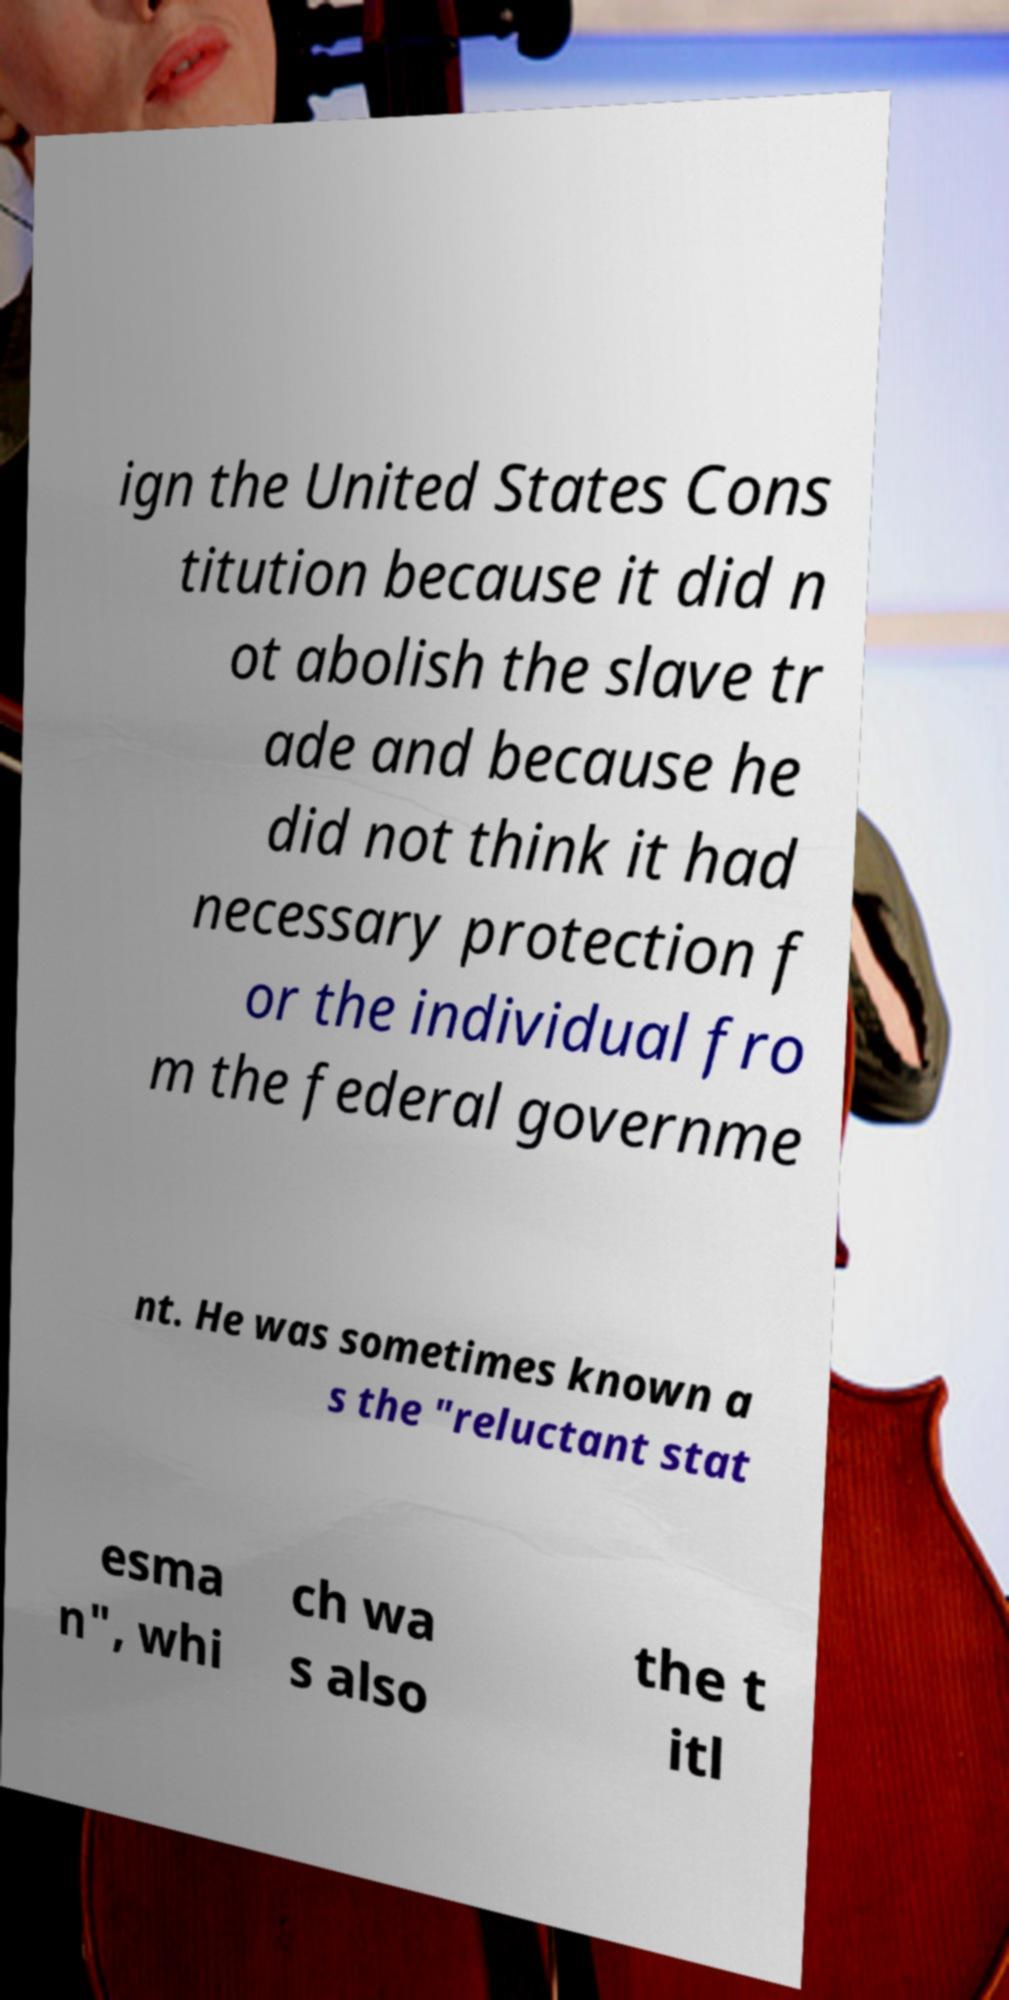Can you accurately transcribe the text from the provided image for me? ign the United States Cons titution because it did n ot abolish the slave tr ade and because he did not think it had necessary protection f or the individual fro m the federal governme nt. He was sometimes known a s the "reluctant stat esma n", whi ch wa s also the t itl 